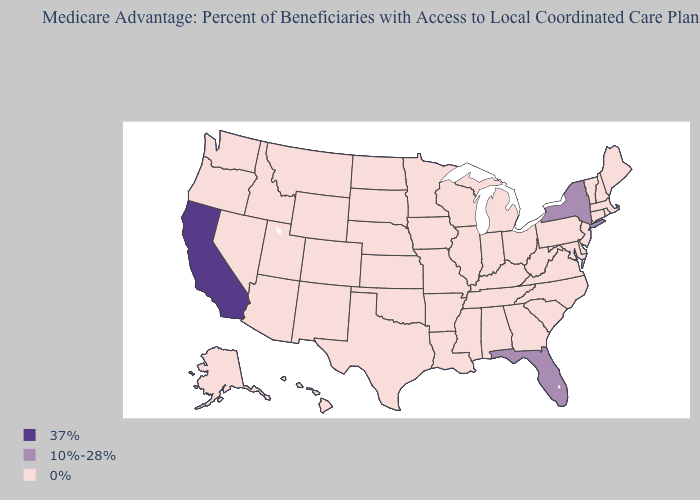Does California have the highest value in the USA?
Be succinct. Yes. Among the states that border Nevada , does Oregon have the lowest value?
Answer briefly. Yes. Name the states that have a value in the range 0%?
Answer briefly. Alaska, Alabama, Arkansas, Arizona, Colorado, Connecticut, Delaware, Georgia, Hawaii, Iowa, Idaho, Illinois, Indiana, Kansas, Kentucky, Louisiana, Massachusetts, Maryland, Maine, Michigan, Minnesota, Missouri, Mississippi, Montana, North Carolina, North Dakota, Nebraska, New Hampshire, New Jersey, New Mexico, Nevada, Ohio, Oklahoma, Oregon, Pennsylvania, Rhode Island, South Carolina, South Dakota, Tennessee, Texas, Utah, Virginia, Vermont, Washington, Wisconsin, West Virginia, Wyoming. Which states hav the highest value in the South?
Quick response, please. Florida. What is the value of Oklahoma?
Answer briefly. 0%. What is the value of New York?
Be succinct. 10%-28%. What is the lowest value in states that border Alabama?
Write a very short answer. 0%. What is the value of Virginia?
Answer briefly. 0%. What is the value of Arkansas?
Concise answer only. 0%. What is the lowest value in the MidWest?
Answer briefly. 0%. What is the value of South Carolina?
Concise answer only. 0%. What is the lowest value in the USA?
Quick response, please. 0%. Which states have the lowest value in the USA?
Write a very short answer. Alaska, Alabama, Arkansas, Arizona, Colorado, Connecticut, Delaware, Georgia, Hawaii, Iowa, Idaho, Illinois, Indiana, Kansas, Kentucky, Louisiana, Massachusetts, Maryland, Maine, Michigan, Minnesota, Missouri, Mississippi, Montana, North Carolina, North Dakota, Nebraska, New Hampshire, New Jersey, New Mexico, Nevada, Ohio, Oklahoma, Oregon, Pennsylvania, Rhode Island, South Carolina, South Dakota, Tennessee, Texas, Utah, Virginia, Vermont, Washington, Wisconsin, West Virginia, Wyoming. Does New York have the highest value in the Northeast?
Quick response, please. Yes. 